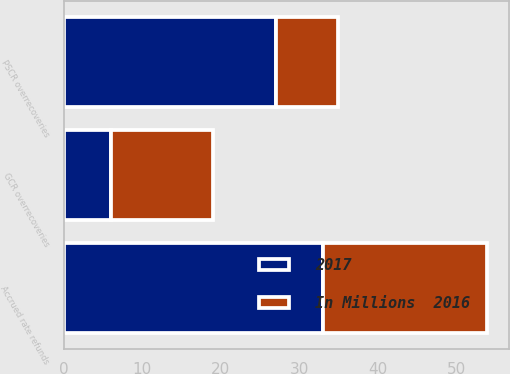Convert chart. <chart><loc_0><loc_0><loc_500><loc_500><stacked_bar_chart><ecel><fcel>PSCR overrecoveries<fcel>GCR overrecoveries<fcel>Accrued rate refunds<nl><fcel>2017<fcel>27<fcel>6<fcel>33<nl><fcel>In Millions  2016<fcel>8<fcel>13<fcel>21<nl></chart> 